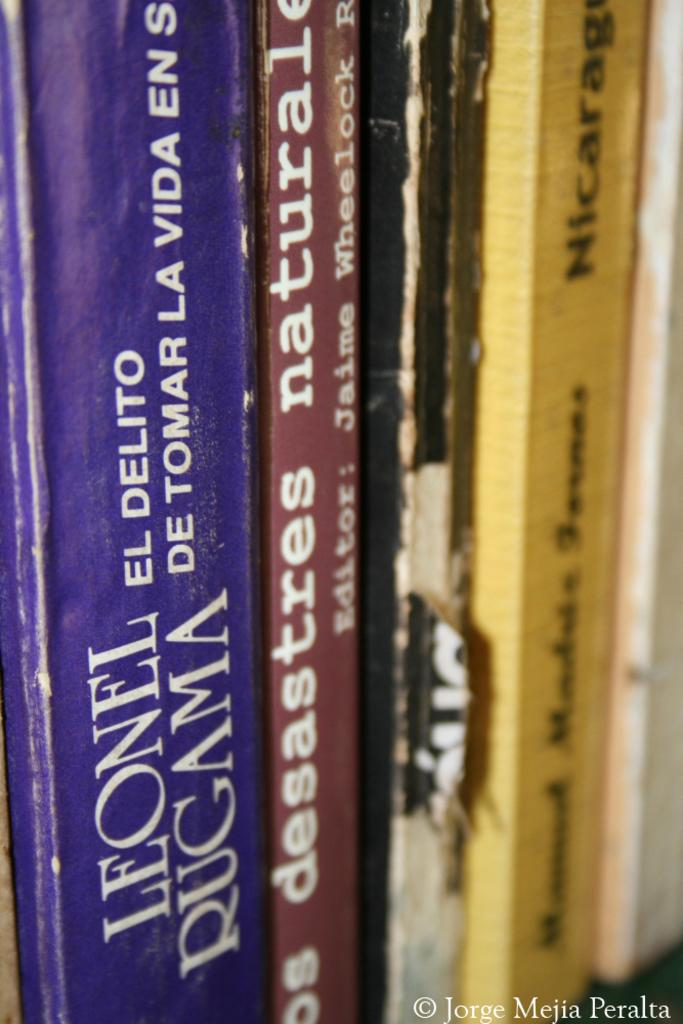<image>
Present a compact description of the photo's key features. a row of books with one of them by leonel rugama 